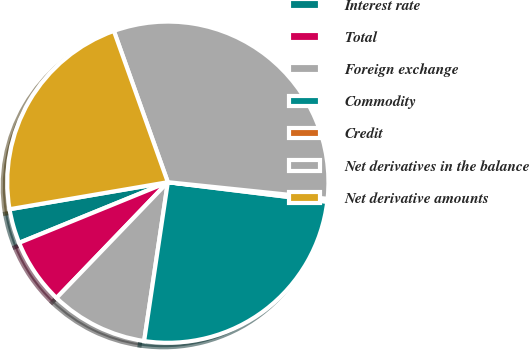Convert chart. <chart><loc_0><loc_0><loc_500><loc_500><pie_chart><fcel>Interest rate<fcel>Total<fcel>Foreign exchange<fcel>Commodity<fcel>Credit<fcel>Net derivatives in the balance<fcel>Net derivative amounts<nl><fcel>3.47%<fcel>6.65%<fcel>9.83%<fcel>25.42%<fcel>0.29%<fcel>32.11%<fcel>22.24%<nl></chart> 